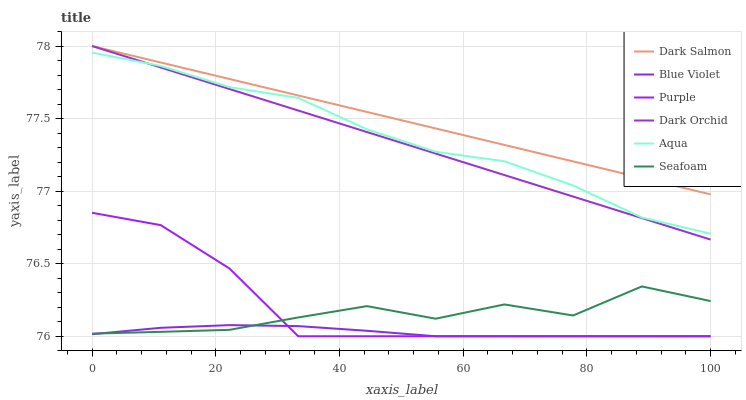Does Blue Violet have the minimum area under the curve?
Answer yes or no. Yes. Does Dark Salmon have the maximum area under the curve?
Answer yes or no. Yes. Does Aqua have the minimum area under the curve?
Answer yes or no. No. Does Aqua have the maximum area under the curve?
Answer yes or no. No. Is Dark Salmon the smoothest?
Answer yes or no. Yes. Is Seafoam the roughest?
Answer yes or no. Yes. Is Aqua the smoothest?
Answer yes or no. No. Is Aqua the roughest?
Answer yes or no. No. Does Purple have the lowest value?
Answer yes or no. Yes. Does Aqua have the lowest value?
Answer yes or no. No. Does Dark Orchid have the highest value?
Answer yes or no. Yes. Does Aqua have the highest value?
Answer yes or no. No. Is Blue Violet less than Dark Orchid?
Answer yes or no. Yes. Is Dark Orchid greater than Blue Violet?
Answer yes or no. Yes. Does Seafoam intersect Purple?
Answer yes or no. Yes. Is Seafoam less than Purple?
Answer yes or no. No. Is Seafoam greater than Purple?
Answer yes or no. No. Does Blue Violet intersect Dark Orchid?
Answer yes or no. No. 